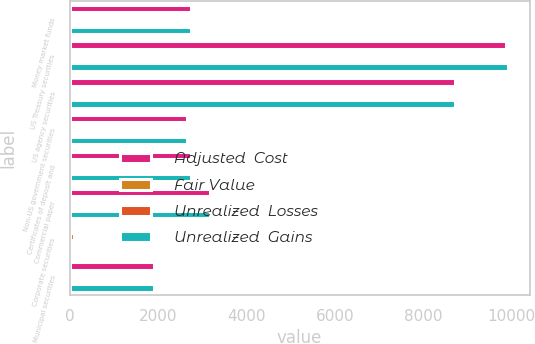Convert chart to OTSL. <chart><loc_0><loc_0><loc_500><loc_500><stacked_bar_chart><ecel><fcel>Money market funds<fcel>US Treasury securities<fcel>US agency securities<fcel>Non-US government securities<fcel>Certificates of deposit and<fcel>Commercial paper<fcel>Corporate securities<fcel>Municipal securities<nl><fcel>Adjusted  Cost<fcel>2753<fcel>9872<fcel>8717<fcel>2648<fcel>2735<fcel>3168<fcel>72<fcel>1899<nl><fcel>Fair Value<fcel>0<fcel>42<fcel>10<fcel>13<fcel>5<fcel>0<fcel>102<fcel>19<nl><fcel>Unrealized  Losses<fcel>0<fcel>0<fcel>0<fcel>0<fcel>1<fcel>0<fcel>9<fcel>1<nl><fcel>Unrealized  Gains<fcel>2753<fcel>9914<fcel>8727<fcel>2661<fcel>2739<fcel>3168<fcel>72<fcel>1917<nl></chart> 